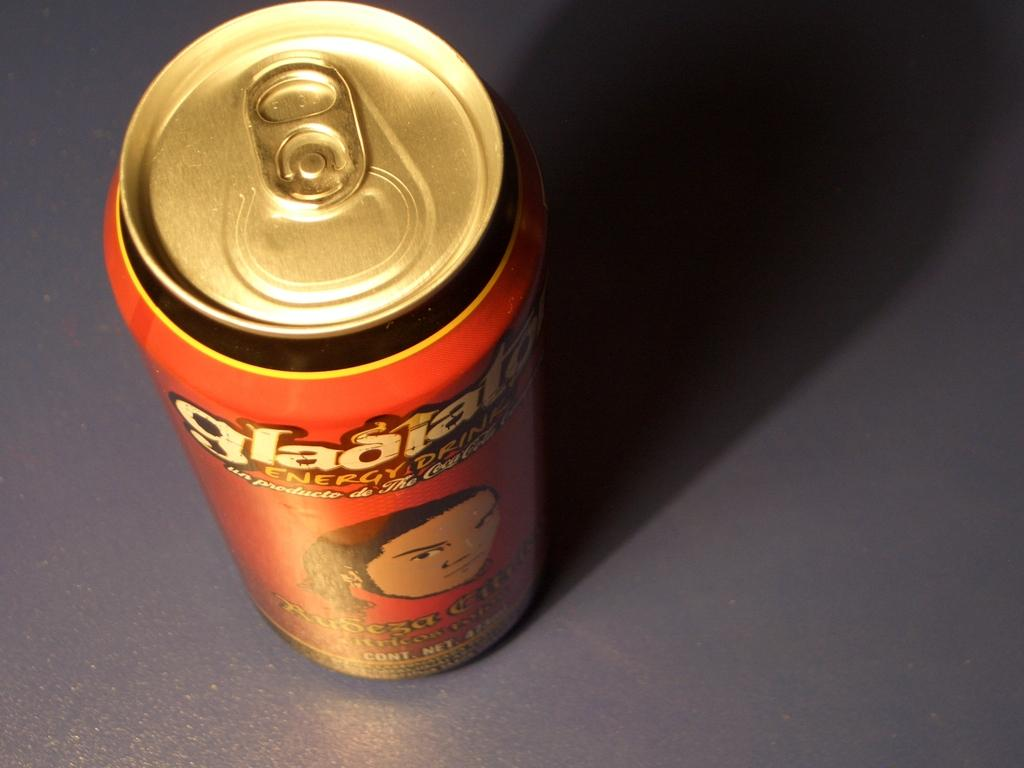Provide a one-sentence caption for the provided image. An orange can has an illusratated face on the front. 